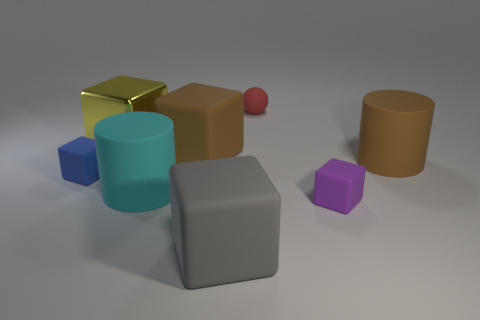Subtract all small blue blocks. How many blocks are left? 4 Add 1 large red shiny cylinders. How many objects exist? 9 Subtract all brown blocks. How many blocks are left? 4 Subtract all cubes. How many objects are left? 3 Subtract all blue blocks. Subtract all yellow balls. How many blocks are left? 4 Subtract all big things. Subtract all red objects. How many objects are left? 2 Add 8 large cyan cylinders. How many large cyan cylinders are left? 9 Add 2 large cyan objects. How many large cyan objects exist? 3 Subtract 0 blue balls. How many objects are left? 8 